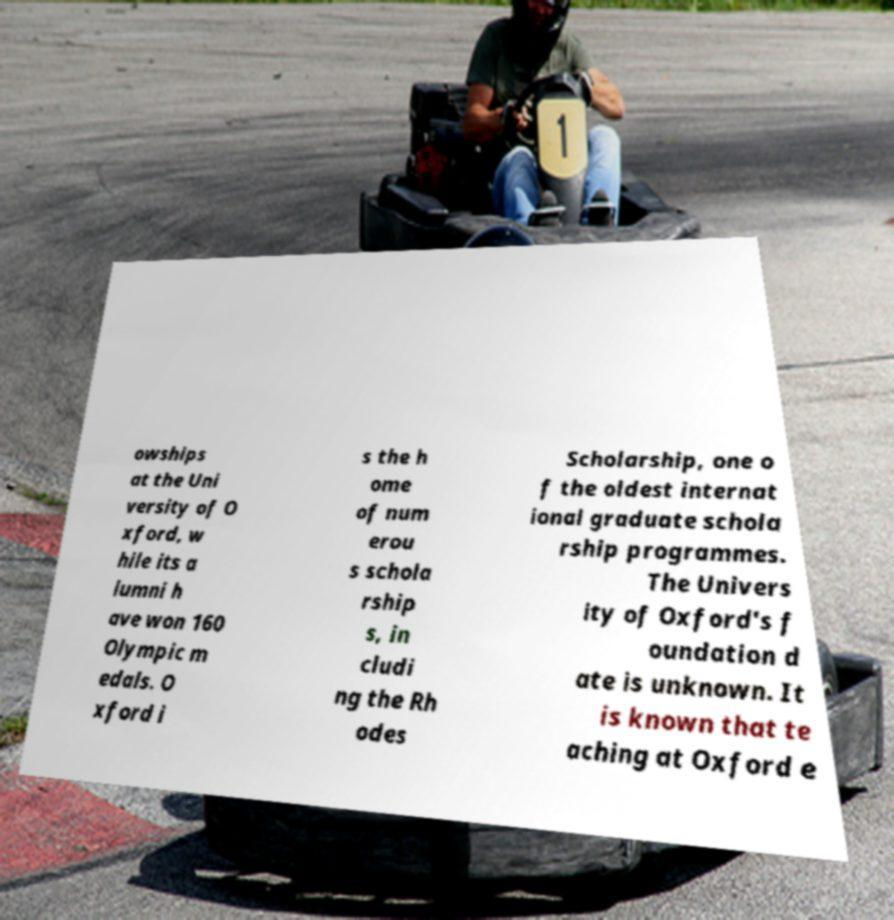Could you assist in decoding the text presented in this image and type it out clearly? owships at the Uni versity of O xford, w hile its a lumni h ave won 160 Olympic m edals. O xford i s the h ome of num erou s schola rship s, in cludi ng the Rh odes Scholarship, one o f the oldest internat ional graduate schola rship programmes. The Univers ity of Oxford's f oundation d ate is unknown. It is known that te aching at Oxford e 